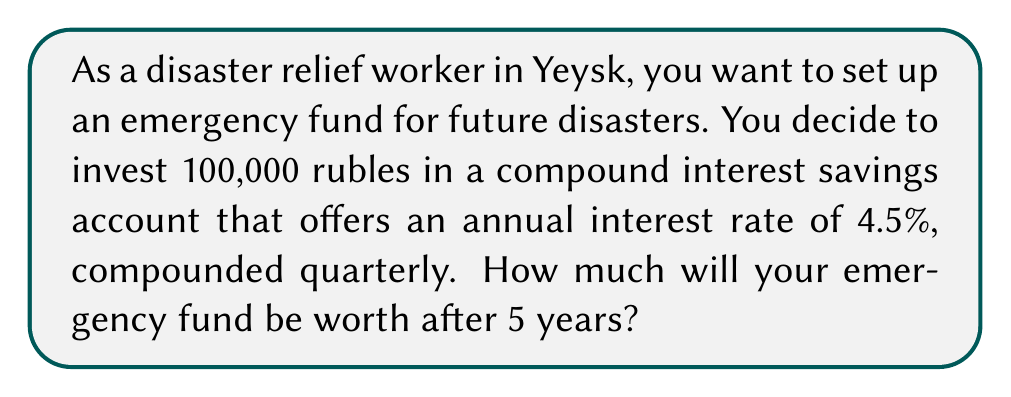Teach me how to tackle this problem. To solve this problem, we'll use the compound interest formula:

$$A = P(1 + \frac{r}{n})^{nt}$$

Where:
$A$ = final amount
$P$ = principal (initial investment)
$r$ = annual interest rate (in decimal form)
$n$ = number of times interest is compounded per year
$t$ = number of years

Given:
$P = 100,000$ rubles
$r = 4.5\% = 0.045$
$n = 4$ (compounded quarterly)
$t = 5$ years

Let's substitute these values into the formula:

$$A = 100,000(1 + \frac{0.045}{4})^{4 \times 5}$$

$$A = 100,000(1 + 0.01125)^{20}$$

$$A = 100,000(1.01125)^{20}$$

Using a calculator or computer:

$$A = 100,000 \times 1.2499689$$

$$A = 124,996.89$$
Answer: After 5 years, the emergency fund will be worth 124,996.89 rubles. 